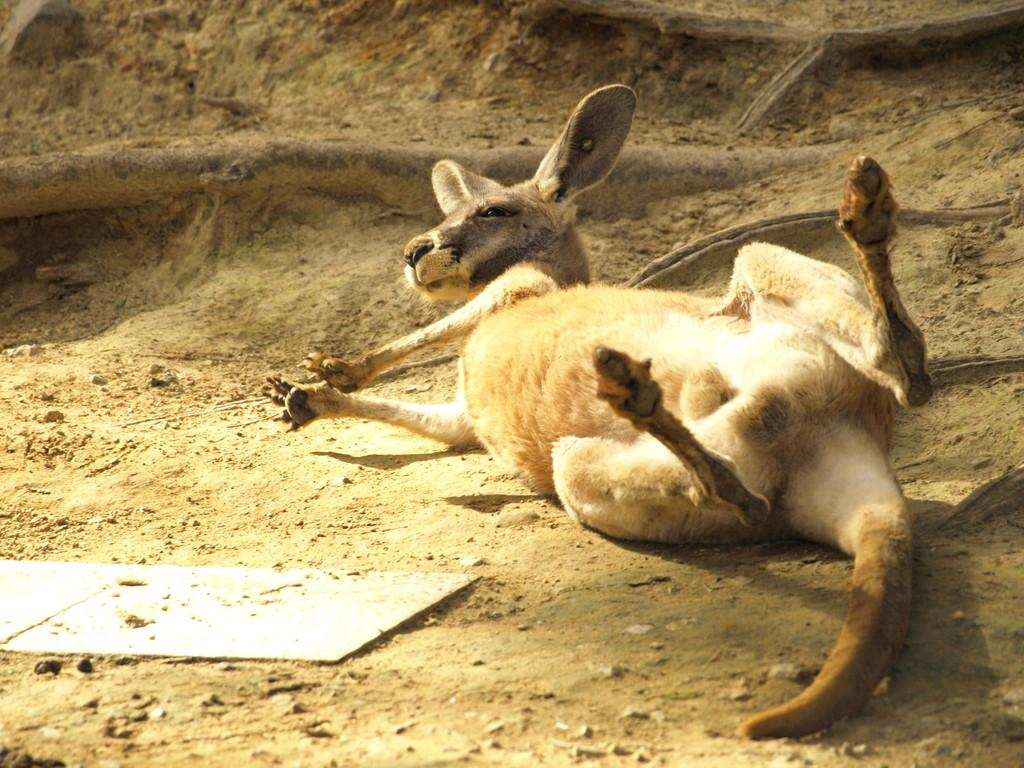What animal is present in the image? There is a deer in the image. What is the position of the deer in the image? The deer is laying on the ground. Where is the deer located in the image? The deer is in the center of the image. What type of wing can be seen on the deer in the image? There are no wings present on the deer in the image. How many oranges are visible in the image? There are no oranges present in the image. 